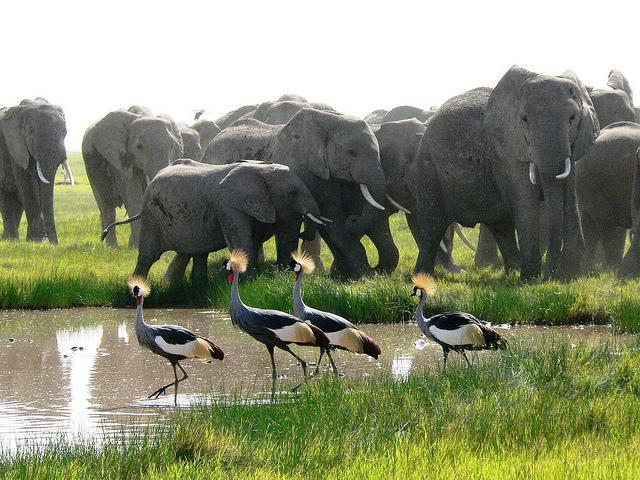How many birds are in the picture?
Give a very brief answer. 4. How many elephants can you see?
Give a very brief answer. 7. How many people are there?
Give a very brief answer. 0. 